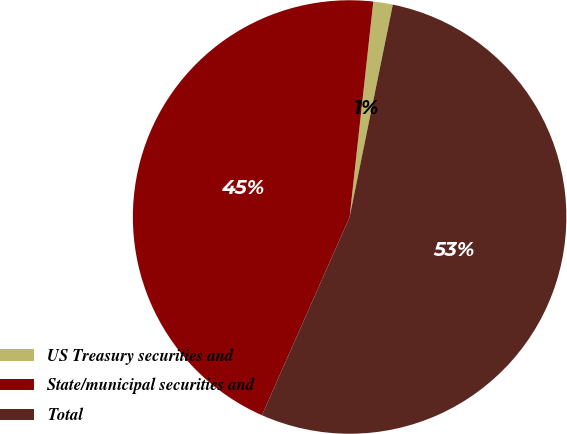Convert chart. <chart><loc_0><loc_0><loc_500><loc_500><pie_chart><fcel>US Treasury securities and<fcel>State/municipal securities and<fcel>Total<nl><fcel>1.45%<fcel>45.12%<fcel>53.44%<nl></chart> 